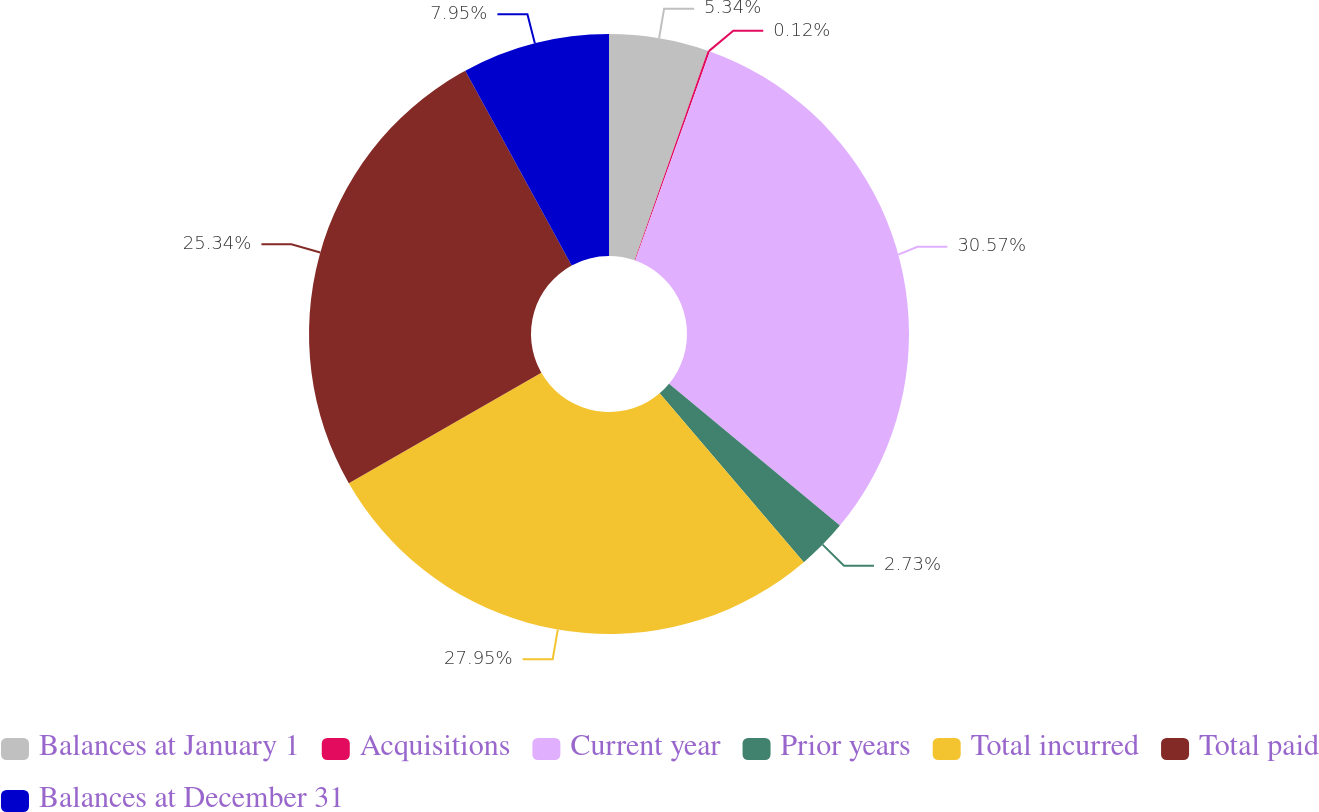Convert chart to OTSL. <chart><loc_0><loc_0><loc_500><loc_500><pie_chart><fcel>Balances at January 1<fcel>Acquisitions<fcel>Current year<fcel>Prior years<fcel>Total incurred<fcel>Total paid<fcel>Balances at December 31<nl><fcel>5.34%<fcel>0.12%<fcel>30.56%<fcel>2.73%<fcel>27.95%<fcel>25.34%<fcel>7.95%<nl></chart> 